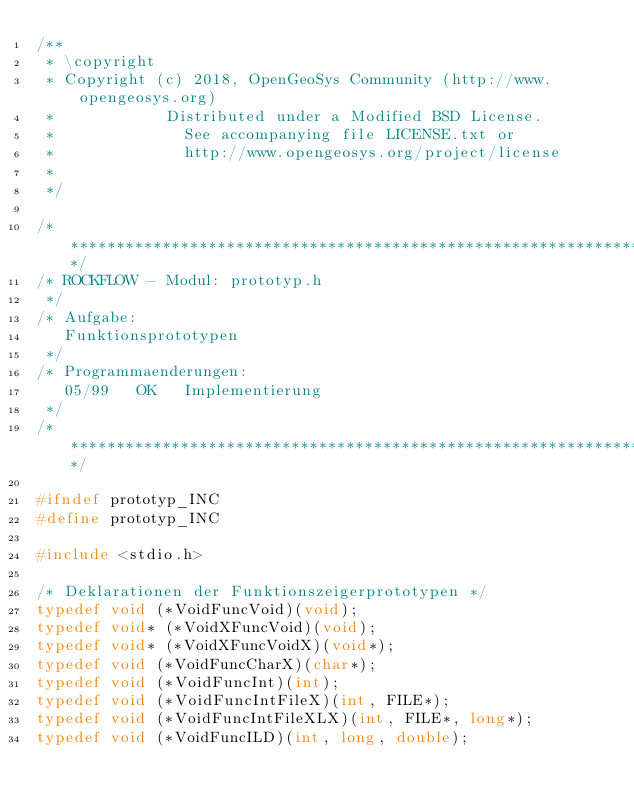<code> <loc_0><loc_0><loc_500><loc_500><_C_>/**
 * \copyright
 * Copyright (c) 2018, OpenGeoSys Community (http://www.opengeosys.org)
 *            Distributed under a Modified BSD License.
 *              See accompanying file LICENSE.txt or
 *              http://www.opengeosys.org/project/license
 *
 */

/**************************************************************************/
/* ROCKFLOW - Modul: prototyp.h
 */
/* Aufgabe:
   Funktionsprototypen
 */
/* Programmaenderungen:
   05/99   OK   Implementierung
 */
/**************************************************************************/

#ifndef prototyp_INC
#define prototyp_INC

#include <stdio.h>

/* Deklarationen der Funktionszeigerprototypen */
typedef void (*VoidFuncVoid)(void);
typedef void* (*VoidXFuncVoid)(void);
typedef void* (*VoidXFuncVoidX)(void*);
typedef void (*VoidFuncCharX)(char*);
typedef void (*VoidFuncInt)(int);
typedef void (*VoidFuncIntFileX)(int, FILE*);
typedef void (*VoidFuncIntFileXLX)(int, FILE*, long*);
typedef void (*VoidFuncILD)(int, long, double);</code> 